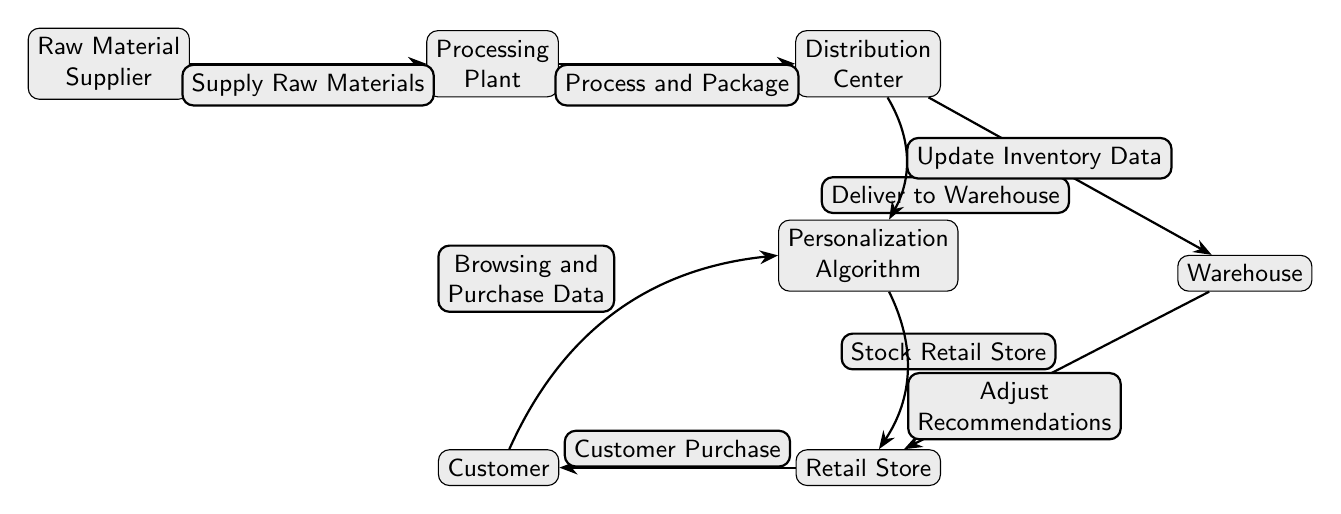What is the first node in the supply chain? The diagram identifies the first node as the "Raw Material Supplier," which is positioned at the leftmost side of the chain.
Answer: Raw Material Supplier How many nodes are there in total? By counting each distinct rectangle in the diagram, we find there are six nodes, including the personalization algorithm.
Answer: 6 What does the processing plant do? The edge labeled "Process and Package" directly connects the processing plant to the distribution center, indicating that this is its function within the supply chain.
Answer: Process and Package Which node receives browsing and purchase data from the customer? The diagram shows that the arrows indicate the flow of data, with a bend left edge labeled "Browsing and Purchase Data" pointing from the customer to the personalization algorithm, making it the recipient.
Answer: Personalization Algorithm How does the distribution center influence recommendation adjustments? The edge labeled "Update Inventory Data" flows from the distribution center to the personalization algorithm, indicating that it informs the algorithm about stock levels, which helps in adjusting recommendations accordingly.
Answer: Update Inventory Data What is the relationship between the retail store and the customer? The edge labeled "Customer Purchase" shows a direct connection from the retail store to the customer, indicating that purchases made by customers occur at this location.
Answer: Customer Purchase What is the last action in the supply chain? The chain ends with the retail store making a sale to the customer, as conveyed by the edge running from the retail store to the customer, indicating a completed transaction.
Answer: Customer Purchase Which node is influenced by both the distribution center and the customer? The personalization algorithm receives input from both the customer through browsing data and from the distribution center through inventory updates, making it influenced by both nodes.
Answer: Personalization Algorithm Where does the final recommendation adjustment originate? The diagram shows an edge labeled "Adjust Recommendations" directed from the personalization algorithm to the retail store, indicating that the final recommendation adjustments are made here.
Answer: Adjust Recommendations 